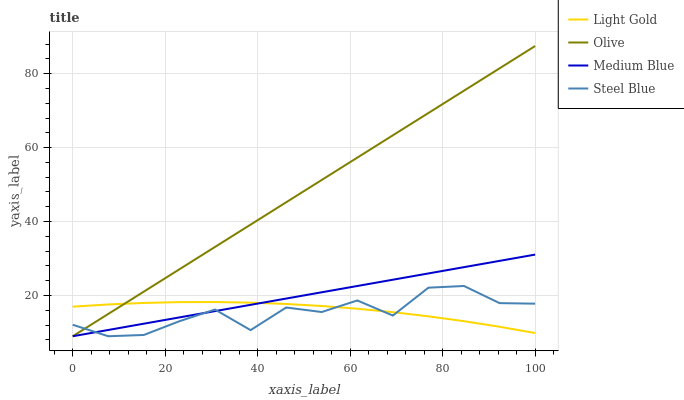Does Steel Blue have the minimum area under the curve?
Answer yes or no. Yes. Does Olive have the maximum area under the curve?
Answer yes or no. Yes. Does Medium Blue have the minimum area under the curve?
Answer yes or no. No. Does Medium Blue have the maximum area under the curve?
Answer yes or no. No. Is Olive the smoothest?
Answer yes or no. Yes. Is Steel Blue the roughest?
Answer yes or no. Yes. Is Medium Blue the smoothest?
Answer yes or no. No. Is Medium Blue the roughest?
Answer yes or no. No. Does Light Gold have the lowest value?
Answer yes or no. No. Does Olive have the highest value?
Answer yes or no. Yes. Does Medium Blue have the highest value?
Answer yes or no. No. Does Steel Blue intersect Light Gold?
Answer yes or no. Yes. Is Steel Blue less than Light Gold?
Answer yes or no. No. Is Steel Blue greater than Light Gold?
Answer yes or no. No. 